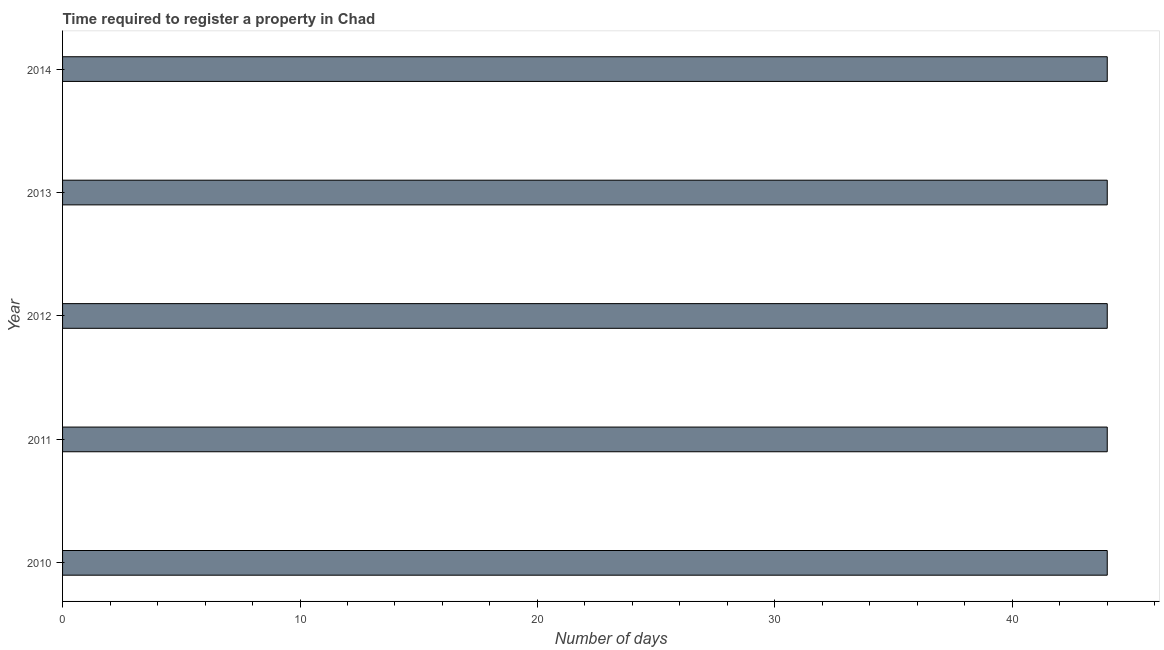Does the graph contain any zero values?
Offer a very short reply. No. What is the title of the graph?
Provide a short and direct response. Time required to register a property in Chad. What is the label or title of the X-axis?
Offer a terse response. Number of days. What is the label or title of the Y-axis?
Your response must be concise. Year. What is the number of days required to register property in 2013?
Provide a short and direct response. 44. In which year was the number of days required to register property maximum?
Offer a terse response. 2010. What is the sum of the number of days required to register property?
Your answer should be compact. 220. Do a majority of the years between 2014 and 2013 (inclusive) have number of days required to register property greater than 22 days?
Offer a terse response. No. What is the ratio of the number of days required to register property in 2011 to that in 2013?
Provide a short and direct response. 1. Is the number of days required to register property in 2011 less than that in 2012?
Provide a short and direct response. No. Is the difference between the number of days required to register property in 2011 and 2012 greater than the difference between any two years?
Your response must be concise. Yes. What is the difference between the highest and the lowest number of days required to register property?
Your answer should be compact. 0. What is the difference between two consecutive major ticks on the X-axis?
Make the answer very short. 10. What is the difference between the Number of days in 2010 and 2012?
Your response must be concise. 0. What is the difference between the Number of days in 2010 and 2014?
Your answer should be compact. 0. What is the difference between the Number of days in 2011 and 2012?
Make the answer very short. 0. What is the difference between the Number of days in 2011 and 2014?
Provide a succinct answer. 0. What is the ratio of the Number of days in 2010 to that in 2011?
Ensure brevity in your answer.  1. What is the ratio of the Number of days in 2010 to that in 2012?
Keep it short and to the point. 1. What is the ratio of the Number of days in 2010 to that in 2014?
Provide a short and direct response. 1. What is the ratio of the Number of days in 2011 to that in 2012?
Provide a succinct answer. 1. What is the ratio of the Number of days in 2012 to that in 2013?
Provide a short and direct response. 1. What is the ratio of the Number of days in 2013 to that in 2014?
Offer a very short reply. 1. 